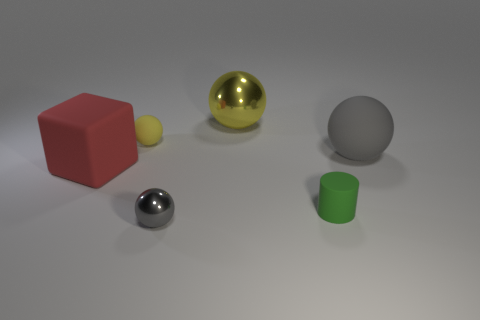Subtract all tiny gray shiny balls. How many balls are left? 3 Subtract all gray blocks. How many yellow balls are left? 2 Add 2 large yellow cubes. How many objects exist? 8 Subtract 2 balls. How many balls are left? 2 Subtract all balls. How many objects are left? 2 Subtract all red spheres. Subtract all green blocks. How many spheres are left? 4 Subtract 0 green cubes. How many objects are left? 6 Subtract all big red cubes. Subtract all tiny brown rubber cylinders. How many objects are left? 5 Add 3 big shiny spheres. How many big shiny spheres are left? 4 Add 5 large purple metallic cylinders. How many large purple metallic cylinders exist? 5 